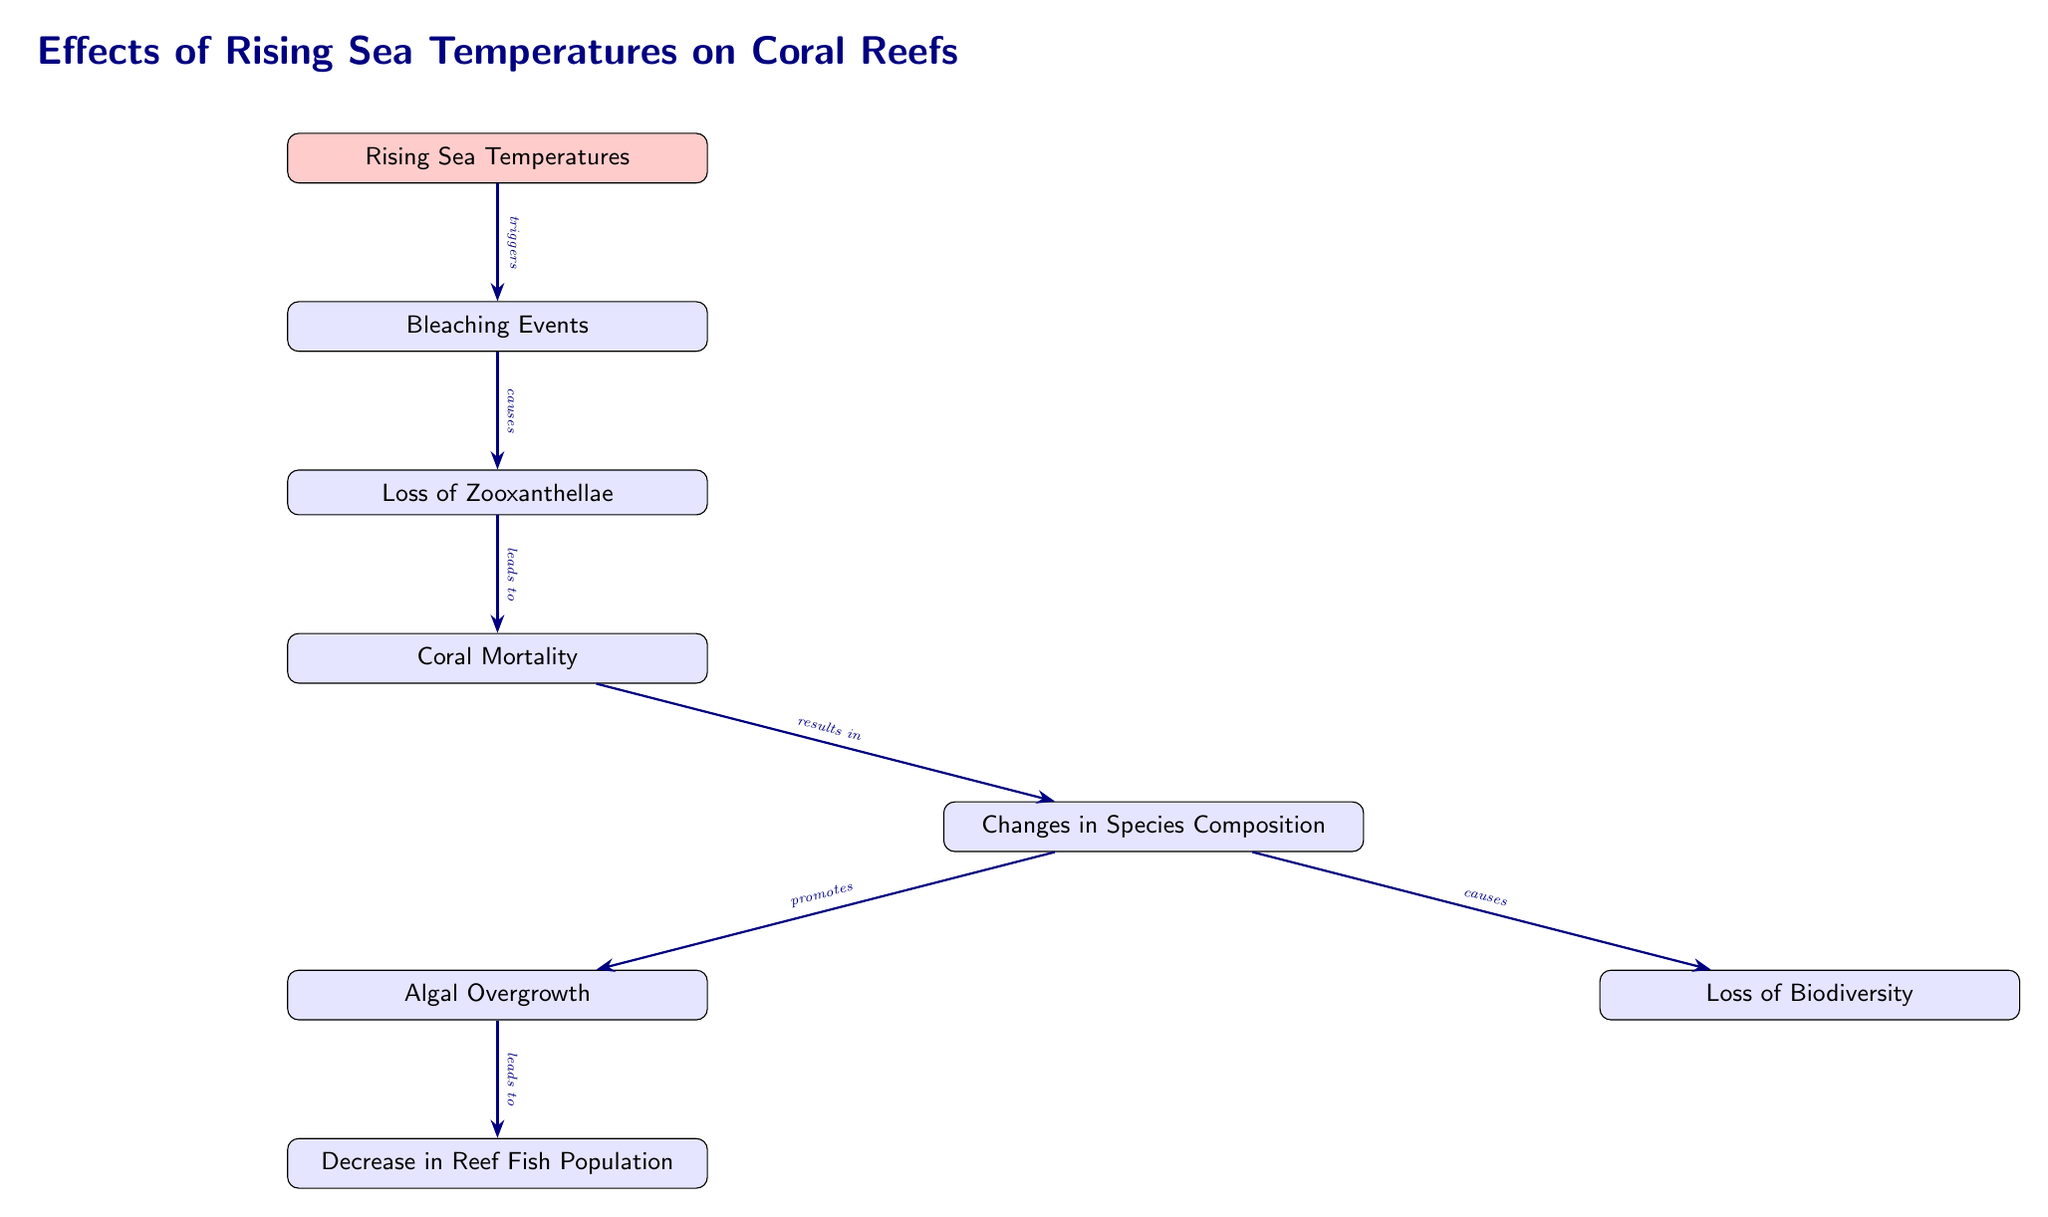What triggers bleaching events? According to the diagram, "Rising Sea Temperatures" is directly linked to bleaching events, as indicated by the arrow showing that rising temperatures trigger these events.
Answer: Rising Sea Temperatures What is the immediate effect of bleaching events? The flowchart shows that bleaching events cause the loss of zooxanthellae, which is the next node connected to bleaching events.
Answer: Loss of Zooxanthellae How many knock-on effects are there from changes in species composition? The diagram indicates that changes in species composition have two knock-on effects: algal overgrowth and loss of biodiversity.
Answer: 2 What is the final outcome of coral mortality? The diagram links coral mortality to changes in species composition, which is the direct outcome indicated by the arrow stemming from coral mortality.
Answer: Changes in Species Composition What leads to a decrease in reef fish population? The flowchart shows that algal overgrowth is the factor that leads to a decrease in reef fish populations, indicated by the arrow connecting these two nodes.
Answer: Algal Overgrowth Which event causes the loss of biodiversity? According to the diagram, changes in species composition directly cause the loss of biodiversity, as shown by the connecting arrow.
Answer: Changes in Species Composition What is the relationship between coral mortality and rising sea temperatures? The diagram illustrates that rising sea temperatures lead to bleaching events, which ultimately result in coral mortality. The connection is established through multiple arrows.
Answer: Leads to What consequence does coral mortality have in the ecosystem? The flowchart indicates that coral mortality results in changes in species composition, highlighting a significant consequence within the ecosystem.
Answer: Changes in Species Composition What effect does rising sea temperatures directly have on coral reefs? The immediate effect shown in the diagram is the occurrence of bleaching events triggered by rising sea temperatures, indicating a direct negative impact.
Answer: Bleaching Events What happens after the loss of zooxanthellae? The diagram indicates that the loss of zooxanthellae leads to coral mortality, showing the immediate consequence of this loss in the ecosystem.
Answer: Coral Mortality 